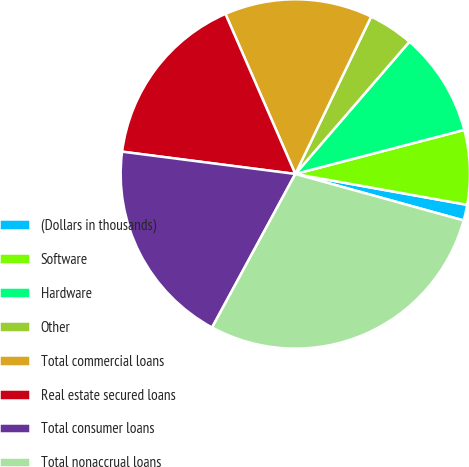<chart> <loc_0><loc_0><loc_500><loc_500><pie_chart><fcel>(Dollars in thousands)<fcel>Software<fcel>Hardware<fcel>Other<fcel>Total commercial loans<fcel>Real estate secured loans<fcel>Total consumer loans<fcel>Total nonaccrual loans<nl><fcel>1.46%<fcel>6.89%<fcel>9.61%<fcel>4.18%<fcel>13.7%<fcel>16.41%<fcel>19.13%<fcel>28.62%<nl></chart> 